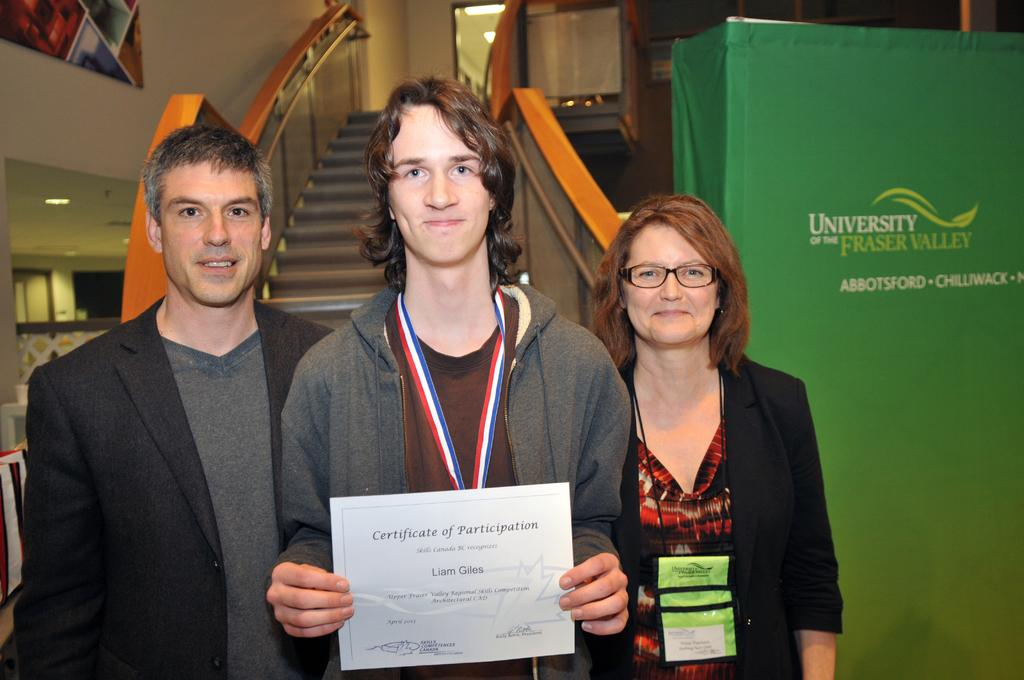<image>
Describe the image concisely. A younger man surrounded by an older man and woman holding a certificate of participation. 